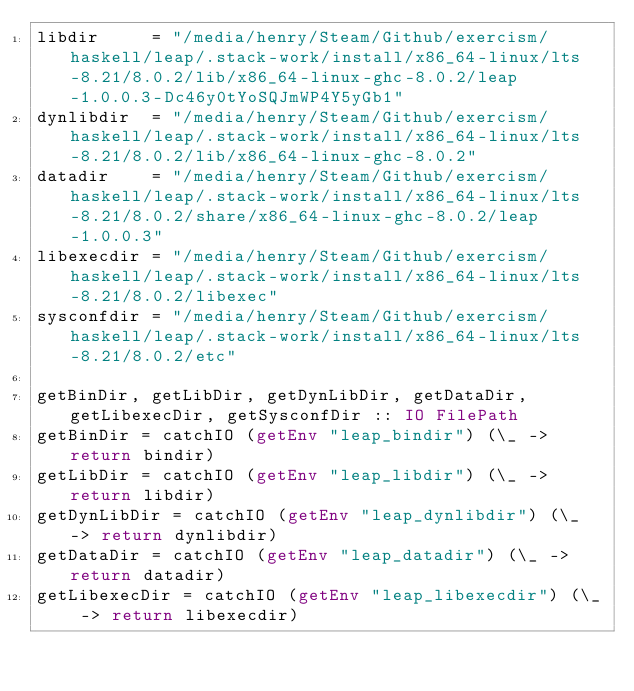<code> <loc_0><loc_0><loc_500><loc_500><_Haskell_>libdir     = "/media/henry/Steam/Github/exercism/haskell/leap/.stack-work/install/x86_64-linux/lts-8.21/8.0.2/lib/x86_64-linux-ghc-8.0.2/leap-1.0.0.3-Dc46y0tYoSQJmWP4Y5yGb1"
dynlibdir  = "/media/henry/Steam/Github/exercism/haskell/leap/.stack-work/install/x86_64-linux/lts-8.21/8.0.2/lib/x86_64-linux-ghc-8.0.2"
datadir    = "/media/henry/Steam/Github/exercism/haskell/leap/.stack-work/install/x86_64-linux/lts-8.21/8.0.2/share/x86_64-linux-ghc-8.0.2/leap-1.0.0.3"
libexecdir = "/media/henry/Steam/Github/exercism/haskell/leap/.stack-work/install/x86_64-linux/lts-8.21/8.0.2/libexec"
sysconfdir = "/media/henry/Steam/Github/exercism/haskell/leap/.stack-work/install/x86_64-linux/lts-8.21/8.0.2/etc"

getBinDir, getLibDir, getDynLibDir, getDataDir, getLibexecDir, getSysconfDir :: IO FilePath
getBinDir = catchIO (getEnv "leap_bindir") (\_ -> return bindir)
getLibDir = catchIO (getEnv "leap_libdir") (\_ -> return libdir)
getDynLibDir = catchIO (getEnv "leap_dynlibdir") (\_ -> return dynlibdir)
getDataDir = catchIO (getEnv "leap_datadir") (\_ -> return datadir)
getLibexecDir = catchIO (getEnv "leap_libexecdir") (\_ -> return libexecdir)</code> 